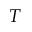<formula> <loc_0><loc_0><loc_500><loc_500>T</formula> 